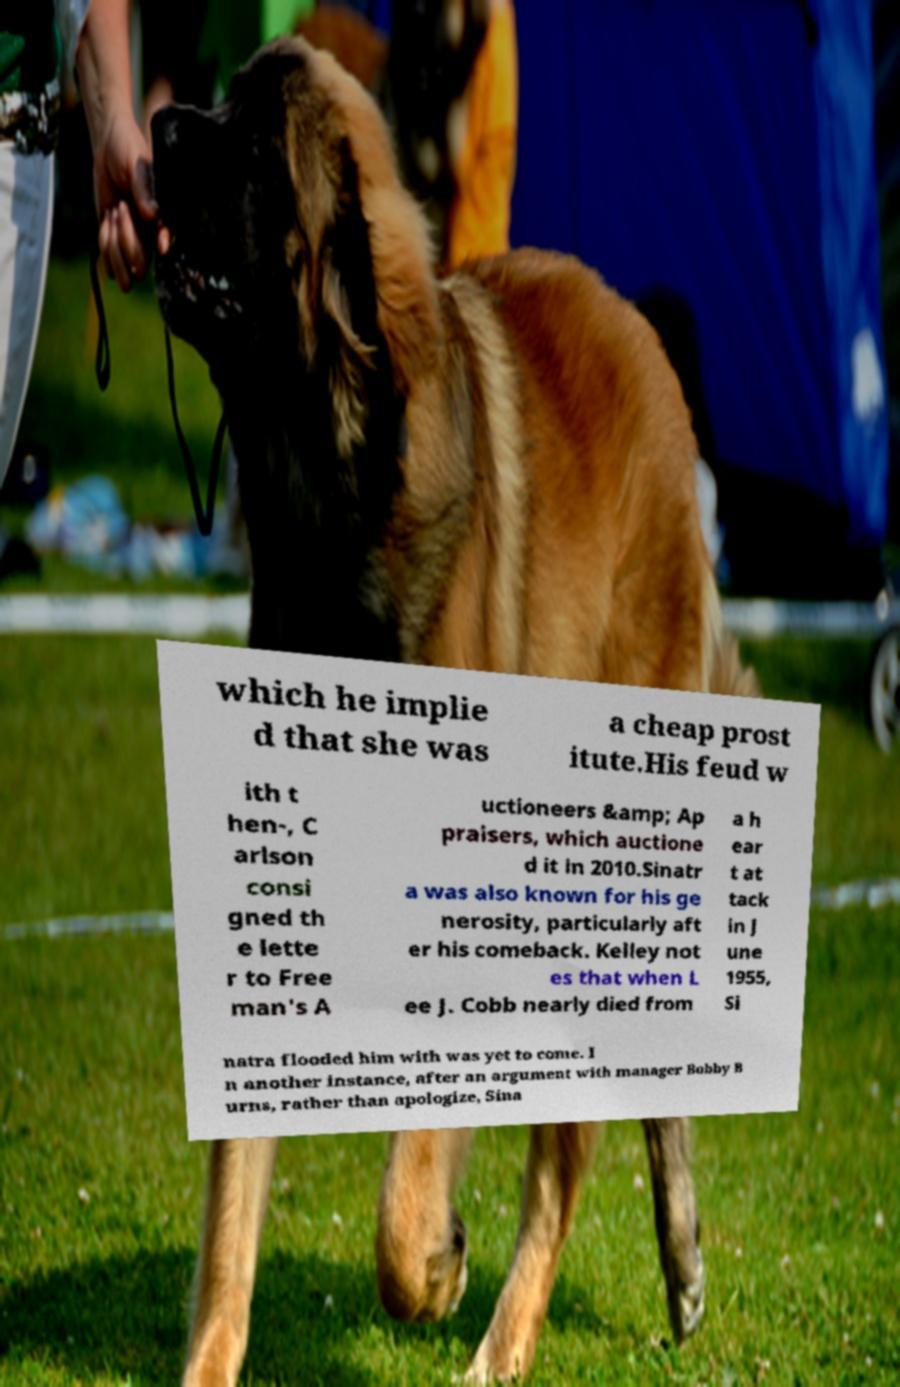Could you extract and type out the text from this image? which he implie d that she was a cheap prost itute.His feud w ith t hen-, C arlson consi gned th e lette r to Free man's A uctioneers &amp; Ap praisers, which auctione d it in 2010.Sinatr a was also known for his ge nerosity, particularly aft er his comeback. Kelley not es that when L ee J. Cobb nearly died from a h ear t at tack in J une 1955, Si natra flooded him with was yet to come. I n another instance, after an argument with manager Bobby B urns, rather than apologize, Sina 